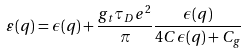<formula> <loc_0><loc_0><loc_500><loc_500>\varepsilon ( q ) = \epsilon ( q ) + \frac { g _ { t } \tau _ { D } e ^ { 2 } } { \pi } \frac { \epsilon ( q ) } { 4 C \epsilon ( q ) + C _ { g } }</formula> 